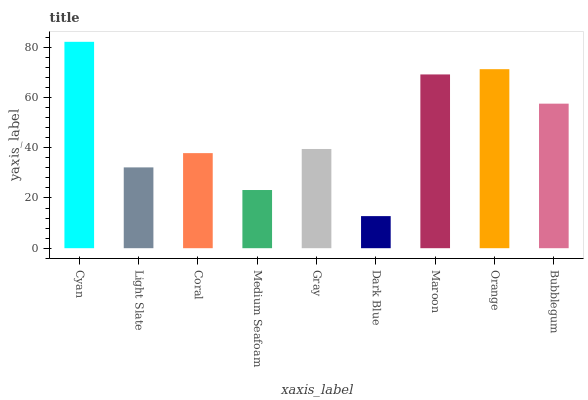Is Dark Blue the minimum?
Answer yes or no. Yes. Is Cyan the maximum?
Answer yes or no. Yes. Is Light Slate the minimum?
Answer yes or no. No. Is Light Slate the maximum?
Answer yes or no. No. Is Cyan greater than Light Slate?
Answer yes or no. Yes. Is Light Slate less than Cyan?
Answer yes or no. Yes. Is Light Slate greater than Cyan?
Answer yes or no. No. Is Cyan less than Light Slate?
Answer yes or no. No. Is Gray the high median?
Answer yes or no. Yes. Is Gray the low median?
Answer yes or no. Yes. Is Cyan the high median?
Answer yes or no. No. Is Medium Seafoam the low median?
Answer yes or no. No. 